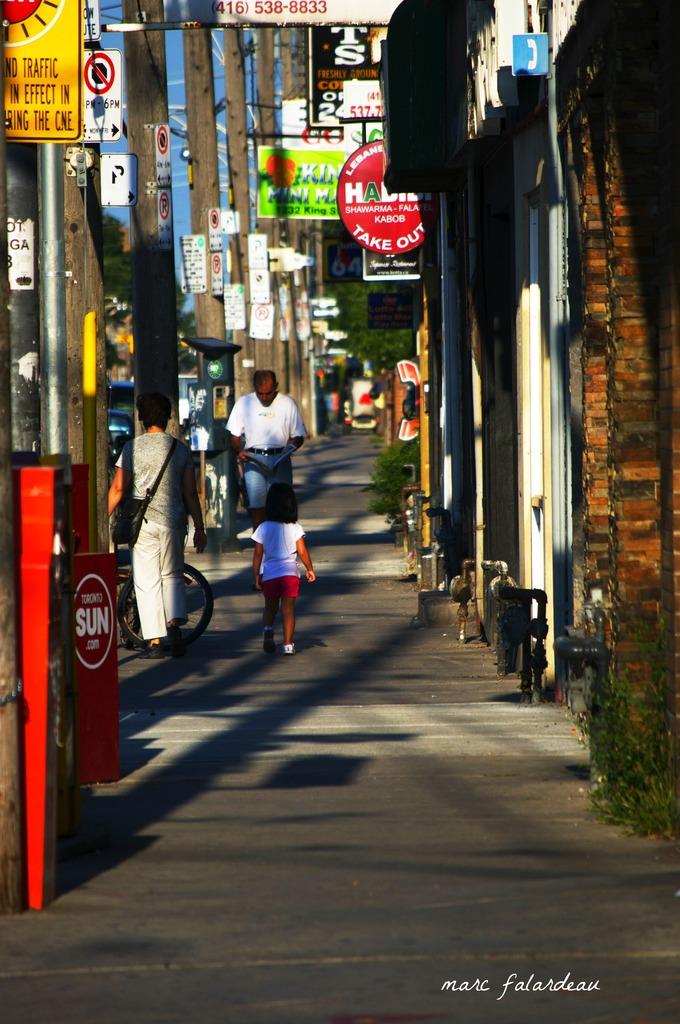What newspaper is in the red machine?
Make the answer very short. Sun. 